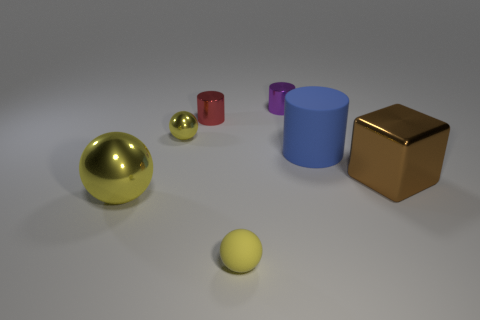Subtract all yellow balls. How many were subtracted if there are1yellow balls left? 2 Add 3 green shiny cylinders. How many objects exist? 10 Subtract all cylinders. How many objects are left? 4 Subtract 0 blue spheres. How many objects are left? 7 Subtract all big blue cylinders. Subtract all yellow spheres. How many objects are left? 3 Add 3 small red objects. How many small red objects are left? 4 Add 2 metal blocks. How many metal blocks exist? 3 